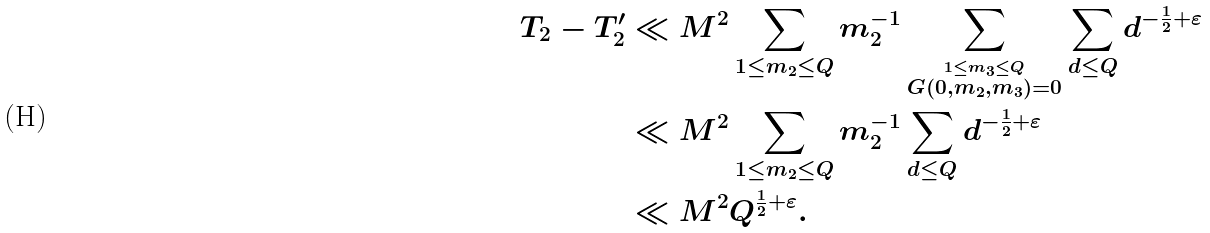Convert formula to latex. <formula><loc_0><loc_0><loc_500><loc_500>T _ { 2 } - T ^ { \prime } _ { 2 } & \ll M ^ { 2 } \sum _ { 1 \leq m _ { 2 } \leq Q } m _ { 2 } ^ { - 1 } \sum _ { \stackrel { 1 \leq m _ { 3 } \leq Q } { G ( 0 , m _ { 2 } , m _ { 3 } ) = 0 } } \sum _ { d \leq Q } d ^ { - \frac { 1 } { 2 } + \varepsilon } \\ & \ll M ^ { 2 } \sum _ { 1 \leq m _ { 2 } \leq Q } m _ { 2 } ^ { - 1 } \sum _ { d \leq Q } d ^ { - \frac { 1 } { 2 } + \varepsilon } \\ & \ll M ^ { 2 } Q ^ { \frac { 1 } { 2 } + \varepsilon } .</formula> 